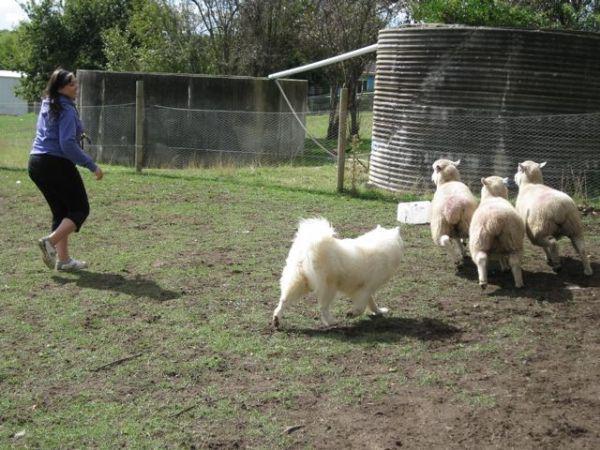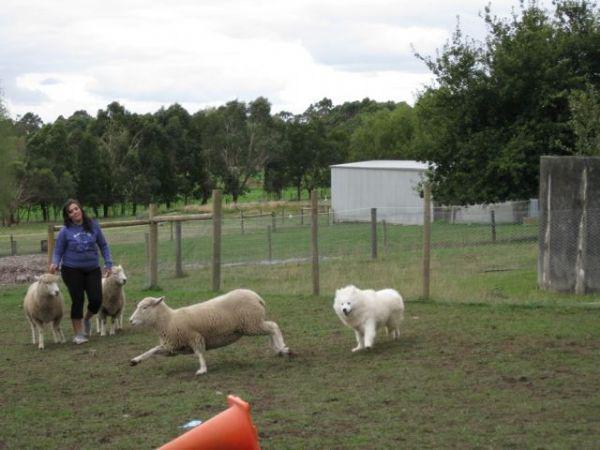The first image is the image on the left, the second image is the image on the right. Given the left and right images, does the statement "A girl wearing a blue sweatshirt is with a white dog and some sheep." hold true? Answer yes or no. Yes. The first image is the image on the left, the second image is the image on the right. Assess this claim about the two images: "There is a dog herding sheep and one woman in each image". Correct or not? Answer yes or no. Yes. 